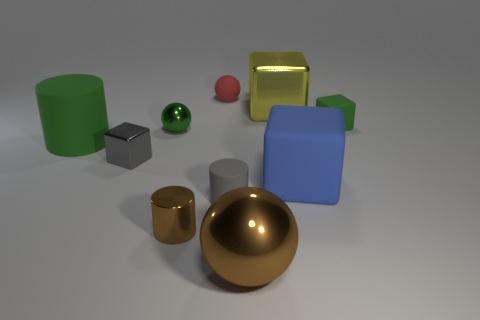What number of things are metal blocks to the right of the red sphere or large brown rubber balls?
Provide a short and direct response. 1. There is a green block; does it have the same size as the matte cylinder in front of the large blue rubber object?
Give a very brief answer. Yes. What is the size of the brown shiny thing that is the same shape as the small red thing?
Provide a succinct answer. Large. What number of small objects are on the left side of the small matte thing on the right side of the tiny gray object on the right side of the tiny green metal sphere?
Keep it short and to the point. 5. How many cylinders are brown metallic things or small rubber things?
Ensure brevity in your answer.  2. What is the color of the large metal thing in front of the large block in front of the large cylinder in front of the small red ball?
Keep it short and to the point. Brown. What number of other objects are the same size as the yellow thing?
Your answer should be compact. 3. There is a shiny object that is the same shape as the big green matte thing; what color is it?
Offer a terse response. Brown. The big cylinder that is the same material as the small gray cylinder is what color?
Provide a short and direct response. Green. Are there the same number of tiny matte cylinders that are to the right of the blue rubber block and large objects?
Provide a short and direct response. No. 